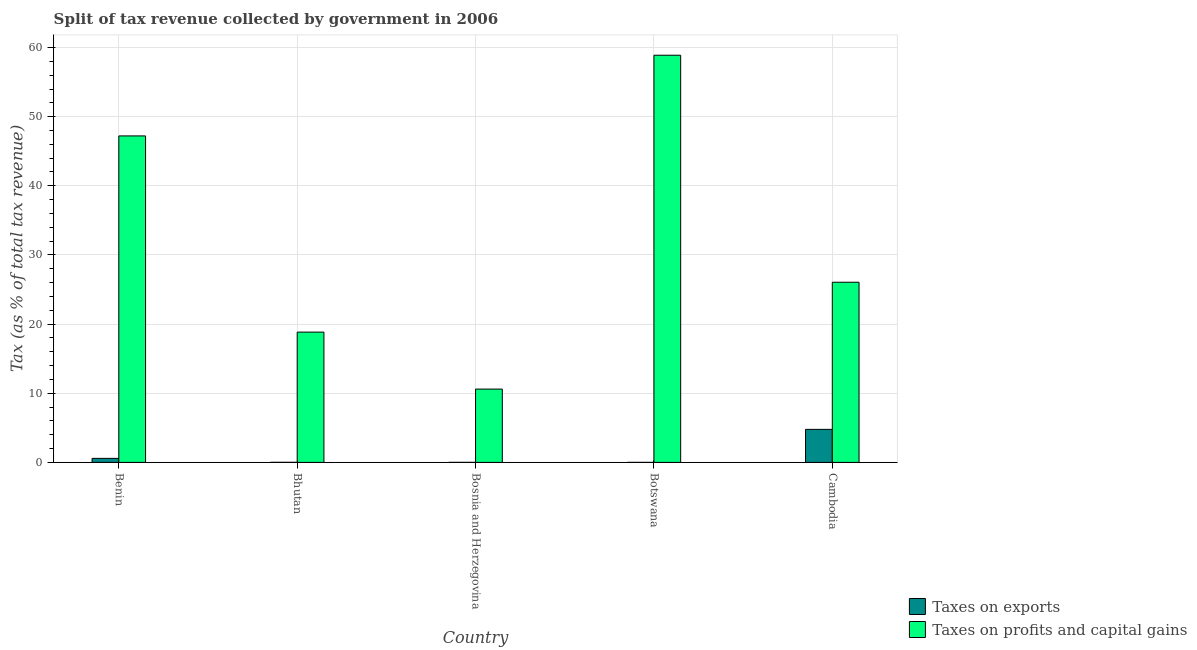How many bars are there on the 1st tick from the right?
Your answer should be compact. 2. What is the label of the 4th group of bars from the left?
Keep it short and to the point. Botswana. What is the percentage of revenue obtained from taxes on profits and capital gains in Cambodia?
Provide a short and direct response. 26.05. Across all countries, what is the maximum percentage of revenue obtained from taxes on exports?
Ensure brevity in your answer.  4.78. Across all countries, what is the minimum percentage of revenue obtained from taxes on profits and capital gains?
Make the answer very short. 10.6. In which country was the percentage of revenue obtained from taxes on profits and capital gains maximum?
Offer a terse response. Botswana. In which country was the percentage of revenue obtained from taxes on profits and capital gains minimum?
Offer a terse response. Bosnia and Herzegovina. What is the total percentage of revenue obtained from taxes on profits and capital gains in the graph?
Give a very brief answer. 161.6. What is the difference between the percentage of revenue obtained from taxes on exports in Bosnia and Herzegovina and that in Cambodia?
Ensure brevity in your answer.  -4.77. What is the difference between the percentage of revenue obtained from taxes on exports in Cambodia and the percentage of revenue obtained from taxes on profits and capital gains in Bosnia and Herzegovina?
Offer a very short reply. -5.82. What is the average percentage of revenue obtained from taxes on profits and capital gains per country?
Provide a short and direct response. 32.32. What is the difference between the percentage of revenue obtained from taxes on exports and percentage of revenue obtained from taxes on profits and capital gains in Benin?
Offer a very short reply. -46.63. What is the ratio of the percentage of revenue obtained from taxes on exports in Benin to that in Botswana?
Offer a very short reply. 257.99. Is the percentage of revenue obtained from taxes on exports in Botswana less than that in Cambodia?
Provide a succinct answer. Yes. Is the difference between the percentage of revenue obtained from taxes on profits and capital gains in Bhutan and Cambodia greater than the difference between the percentage of revenue obtained from taxes on exports in Bhutan and Cambodia?
Make the answer very short. No. What is the difference between the highest and the second highest percentage of revenue obtained from taxes on profits and capital gains?
Offer a terse response. 11.67. What is the difference between the highest and the lowest percentage of revenue obtained from taxes on profits and capital gains?
Your response must be concise. 48.28. What does the 1st bar from the left in Cambodia represents?
Provide a short and direct response. Taxes on exports. What does the 1st bar from the right in Botswana represents?
Give a very brief answer. Taxes on profits and capital gains. How many bars are there?
Offer a terse response. 10. Are all the bars in the graph horizontal?
Your response must be concise. No. Are the values on the major ticks of Y-axis written in scientific E-notation?
Your response must be concise. No. How many legend labels are there?
Your answer should be very brief. 2. How are the legend labels stacked?
Your response must be concise. Vertical. What is the title of the graph?
Your answer should be compact. Split of tax revenue collected by government in 2006. Does "Transport services" appear as one of the legend labels in the graph?
Provide a short and direct response. No. What is the label or title of the X-axis?
Give a very brief answer. Country. What is the label or title of the Y-axis?
Keep it short and to the point. Tax (as % of total tax revenue). What is the Tax (as % of total tax revenue) in Taxes on exports in Benin?
Ensure brevity in your answer.  0.58. What is the Tax (as % of total tax revenue) in Taxes on profits and capital gains in Benin?
Make the answer very short. 47.22. What is the Tax (as % of total tax revenue) in Taxes on exports in Bhutan?
Keep it short and to the point. 0.01. What is the Tax (as % of total tax revenue) of Taxes on profits and capital gains in Bhutan?
Keep it short and to the point. 18.84. What is the Tax (as % of total tax revenue) in Taxes on exports in Bosnia and Herzegovina?
Offer a terse response. 0. What is the Tax (as % of total tax revenue) of Taxes on profits and capital gains in Bosnia and Herzegovina?
Offer a terse response. 10.6. What is the Tax (as % of total tax revenue) of Taxes on exports in Botswana?
Give a very brief answer. 0. What is the Tax (as % of total tax revenue) of Taxes on profits and capital gains in Botswana?
Ensure brevity in your answer.  58.88. What is the Tax (as % of total tax revenue) in Taxes on exports in Cambodia?
Give a very brief answer. 4.78. What is the Tax (as % of total tax revenue) of Taxes on profits and capital gains in Cambodia?
Ensure brevity in your answer.  26.05. Across all countries, what is the maximum Tax (as % of total tax revenue) in Taxes on exports?
Give a very brief answer. 4.78. Across all countries, what is the maximum Tax (as % of total tax revenue) in Taxes on profits and capital gains?
Provide a succinct answer. 58.88. Across all countries, what is the minimum Tax (as % of total tax revenue) in Taxes on exports?
Ensure brevity in your answer.  0. Across all countries, what is the minimum Tax (as % of total tax revenue) of Taxes on profits and capital gains?
Offer a terse response. 10.6. What is the total Tax (as % of total tax revenue) of Taxes on exports in the graph?
Your answer should be very brief. 5.38. What is the total Tax (as % of total tax revenue) of Taxes on profits and capital gains in the graph?
Your answer should be very brief. 161.6. What is the difference between the Tax (as % of total tax revenue) in Taxes on exports in Benin and that in Bhutan?
Your answer should be very brief. 0.57. What is the difference between the Tax (as % of total tax revenue) in Taxes on profits and capital gains in Benin and that in Bhutan?
Ensure brevity in your answer.  28.38. What is the difference between the Tax (as % of total tax revenue) of Taxes on exports in Benin and that in Bosnia and Herzegovina?
Make the answer very short. 0.58. What is the difference between the Tax (as % of total tax revenue) in Taxes on profits and capital gains in Benin and that in Bosnia and Herzegovina?
Offer a terse response. 36.62. What is the difference between the Tax (as % of total tax revenue) of Taxes on exports in Benin and that in Botswana?
Your response must be concise. 0.58. What is the difference between the Tax (as % of total tax revenue) of Taxes on profits and capital gains in Benin and that in Botswana?
Make the answer very short. -11.67. What is the difference between the Tax (as % of total tax revenue) of Taxes on exports in Benin and that in Cambodia?
Your answer should be very brief. -4.19. What is the difference between the Tax (as % of total tax revenue) of Taxes on profits and capital gains in Benin and that in Cambodia?
Your response must be concise. 21.16. What is the difference between the Tax (as % of total tax revenue) in Taxes on exports in Bhutan and that in Bosnia and Herzegovina?
Make the answer very short. 0.01. What is the difference between the Tax (as % of total tax revenue) in Taxes on profits and capital gains in Bhutan and that in Bosnia and Herzegovina?
Give a very brief answer. 8.24. What is the difference between the Tax (as % of total tax revenue) in Taxes on exports in Bhutan and that in Botswana?
Make the answer very short. 0.01. What is the difference between the Tax (as % of total tax revenue) of Taxes on profits and capital gains in Bhutan and that in Botswana?
Offer a terse response. -40.04. What is the difference between the Tax (as % of total tax revenue) of Taxes on exports in Bhutan and that in Cambodia?
Give a very brief answer. -4.77. What is the difference between the Tax (as % of total tax revenue) in Taxes on profits and capital gains in Bhutan and that in Cambodia?
Offer a very short reply. -7.21. What is the difference between the Tax (as % of total tax revenue) in Taxes on exports in Bosnia and Herzegovina and that in Botswana?
Provide a succinct answer. 0. What is the difference between the Tax (as % of total tax revenue) in Taxes on profits and capital gains in Bosnia and Herzegovina and that in Botswana?
Ensure brevity in your answer.  -48.28. What is the difference between the Tax (as % of total tax revenue) of Taxes on exports in Bosnia and Herzegovina and that in Cambodia?
Offer a terse response. -4.77. What is the difference between the Tax (as % of total tax revenue) in Taxes on profits and capital gains in Bosnia and Herzegovina and that in Cambodia?
Make the answer very short. -15.45. What is the difference between the Tax (as % of total tax revenue) of Taxes on exports in Botswana and that in Cambodia?
Your answer should be compact. -4.78. What is the difference between the Tax (as % of total tax revenue) in Taxes on profits and capital gains in Botswana and that in Cambodia?
Keep it short and to the point. 32.83. What is the difference between the Tax (as % of total tax revenue) of Taxes on exports in Benin and the Tax (as % of total tax revenue) of Taxes on profits and capital gains in Bhutan?
Your answer should be compact. -18.26. What is the difference between the Tax (as % of total tax revenue) in Taxes on exports in Benin and the Tax (as % of total tax revenue) in Taxes on profits and capital gains in Bosnia and Herzegovina?
Ensure brevity in your answer.  -10.02. What is the difference between the Tax (as % of total tax revenue) in Taxes on exports in Benin and the Tax (as % of total tax revenue) in Taxes on profits and capital gains in Botswana?
Your answer should be very brief. -58.3. What is the difference between the Tax (as % of total tax revenue) of Taxes on exports in Benin and the Tax (as % of total tax revenue) of Taxes on profits and capital gains in Cambodia?
Keep it short and to the point. -25.47. What is the difference between the Tax (as % of total tax revenue) of Taxes on exports in Bhutan and the Tax (as % of total tax revenue) of Taxes on profits and capital gains in Bosnia and Herzegovina?
Your response must be concise. -10.59. What is the difference between the Tax (as % of total tax revenue) of Taxes on exports in Bhutan and the Tax (as % of total tax revenue) of Taxes on profits and capital gains in Botswana?
Your answer should be compact. -58.88. What is the difference between the Tax (as % of total tax revenue) of Taxes on exports in Bhutan and the Tax (as % of total tax revenue) of Taxes on profits and capital gains in Cambodia?
Your response must be concise. -26.05. What is the difference between the Tax (as % of total tax revenue) of Taxes on exports in Bosnia and Herzegovina and the Tax (as % of total tax revenue) of Taxes on profits and capital gains in Botswana?
Give a very brief answer. -58.88. What is the difference between the Tax (as % of total tax revenue) of Taxes on exports in Bosnia and Herzegovina and the Tax (as % of total tax revenue) of Taxes on profits and capital gains in Cambodia?
Ensure brevity in your answer.  -26.05. What is the difference between the Tax (as % of total tax revenue) of Taxes on exports in Botswana and the Tax (as % of total tax revenue) of Taxes on profits and capital gains in Cambodia?
Provide a short and direct response. -26.05. What is the average Tax (as % of total tax revenue) of Taxes on exports per country?
Provide a short and direct response. 1.08. What is the average Tax (as % of total tax revenue) in Taxes on profits and capital gains per country?
Offer a terse response. 32.32. What is the difference between the Tax (as % of total tax revenue) of Taxes on exports and Tax (as % of total tax revenue) of Taxes on profits and capital gains in Benin?
Offer a very short reply. -46.63. What is the difference between the Tax (as % of total tax revenue) in Taxes on exports and Tax (as % of total tax revenue) in Taxes on profits and capital gains in Bhutan?
Offer a terse response. -18.83. What is the difference between the Tax (as % of total tax revenue) of Taxes on exports and Tax (as % of total tax revenue) of Taxes on profits and capital gains in Bosnia and Herzegovina?
Your answer should be compact. -10.6. What is the difference between the Tax (as % of total tax revenue) in Taxes on exports and Tax (as % of total tax revenue) in Taxes on profits and capital gains in Botswana?
Keep it short and to the point. -58.88. What is the difference between the Tax (as % of total tax revenue) in Taxes on exports and Tax (as % of total tax revenue) in Taxes on profits and capital gains in Cambodia?
Give a very brief answer. -21.28. What is the ratio of the Tax (as % of total tax revenue) in Taxes on exports in Benin to that in Bhutan?
Your answer should be very brief. 63.22. What is the ratio of the Tax (as % of total tax revenue) of Taxes on profits and capital gains in Benin to that in Bhutan?
Give a very brief answer. 2.51. What is the ratio of the Tax (as % of total tax revenue) in Taxes on exports in Benin to that in Bosnia and Herzegovina?
Your answer should be compact. 173.62. What is the ratio of the Tax (as % of total tax revenue) in Taxes on profits and capital gains in Benin to that in Bosnia and Herzegovina?
Offer a very short reply. 4.45. What is the ratio of the Tax (as % of total tax revenue) in Taxes on exports in Benin to that in Botswana?
Your response must be concise. 257.99. What is the ratio of the Tax (as % of total tax revenue) in Taxes on profits and capital gains in Benin to that in Botswana?
Ensure brevity in your answer.  0.8. What is the ratio of the Tax (as % of total tax revenue) in Taxes on exports in Benin to that in Cambodia?
Give a very brief answer. 0.12. What is the ratio of the Tax (as % of total tax revenue) in Taxes on profits and capital gains in Benin to that in Cambodia?
Your response must be concise. 1.81. What is the ratio of the Tax (as % of total tax revenue) in Taxes on exports in Bhutan to that in Bosnia and Herzegovina?
Your answer should be very brief. 2.75. What is the ratio of the Tax (as % of total tax revenue) of Taxes on profits and capital gains in Bhutan to that in Bosnia and Herzegovina?
Provide a short and direct response. 1.78. What is the ratio of the Tax (as % of total tax revenue) in Taxes on exports in Bhutan to that in Botswana?
Your answer should be compact. 4.08. What is the ratio of the Tax (as % of total tax revenue) in Taxes on profits and capital gains in Bhutan to that in Botswana?
Your response must be concise. 0.32. What is the ratio of the Tax (as % of total tax revenue) in Taxes on exports in Bhutan to that in Cambodia?
Give a very brief answer. 0. What is the ratio of the Tax (as % of total tax revenue) of Taxes on profits and capital gains in Bhutan to that in Cambodia?
Provide a succinct answer. 0.72. What is the ratio of the Tax (as % of total tax revenue) in Taxes on exports in Bosnia and Herzegovina to that in Botswana?
Your answer should be compact. 1.49. What is the ratio of the Tax (as % of total tax revenue) of Taxes on profits and capital gains in Bosnia and Herzegovina to that in Botswana?
Your response must be concise. 0.18. What is the ratio of the Tax (as % of total tax revenue) of Taxes on exports in Bosnia and Herzegovina to that in Cambodia?
Make the answer very short. 0. What is the ratio of the Tax (as % of total tax revenue) in Taxes on profits and capital gains in Bosnia and Herzegovina to that in Cambodia?
Give a very brief answer. 0.41. What is the ratio of the Tax (as % of total tax revenue) of Taxes on exports in Botswana to that in Cambodia?
Your response must be concise. 0. What is the ratio of the Tax (as % of total tax revenue) in Taxes on profits and capital gains in Botswana to that in Cambodia?
Your answer should be very brief. 2.26. What is the difference between the highest and the second highest Tax (as % of total tax revenue) in Taxes on exports?
Offer a terse response. 4.19. What is the difference between the highest and the second highest Tax (as % of total tax revenue) in Taxes on profits and capital gains?
Your response must be concise. 11.67. What is the difference between the highest and the lowest Tax (as % of total tax revenue) in Taxes on exports?
Make the answer very short. 4.78. What is the difference between the highest and the lowest Tax (as % of total tax revenue) in Taxes on profits and capital gains?
Offer a terse response. 48.28. 